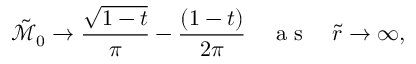Convert formula to latex. <formula><loc_0><loc_0><loc_500><loc_500>\tilde { \mathcal { M } } _ { 0 } \rightarrow \frac { \sqrt { 1 - t } } { \pi } - \frac { ( 1 - t ) } { 2 \pi } \quad a s \quad \tilde { r } \rightarrow \infty ,</formula> 